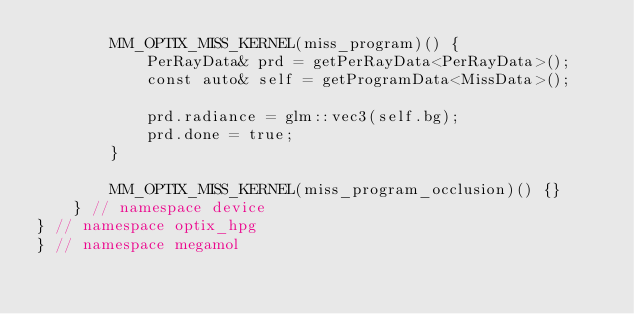<code> <loc_0><loc_0><loc_500><loc_500><_Cuda_>        MM_OPTIX_MISS_KERNEL(miss_program)() {
            PerRayData& prd = getPerRayData<PerRayData>();
            const auto& self = getProgramData<MissData>();

            prd.radiance = glm::vec3(self.bg);
            prd.done = true;
        }

        MM_OPTIX_MISS_KERNEL(miss_program_occlusion)() {}
    } // namespace device
} // namespace optix_hpg
} // namespace megamol
</code> 